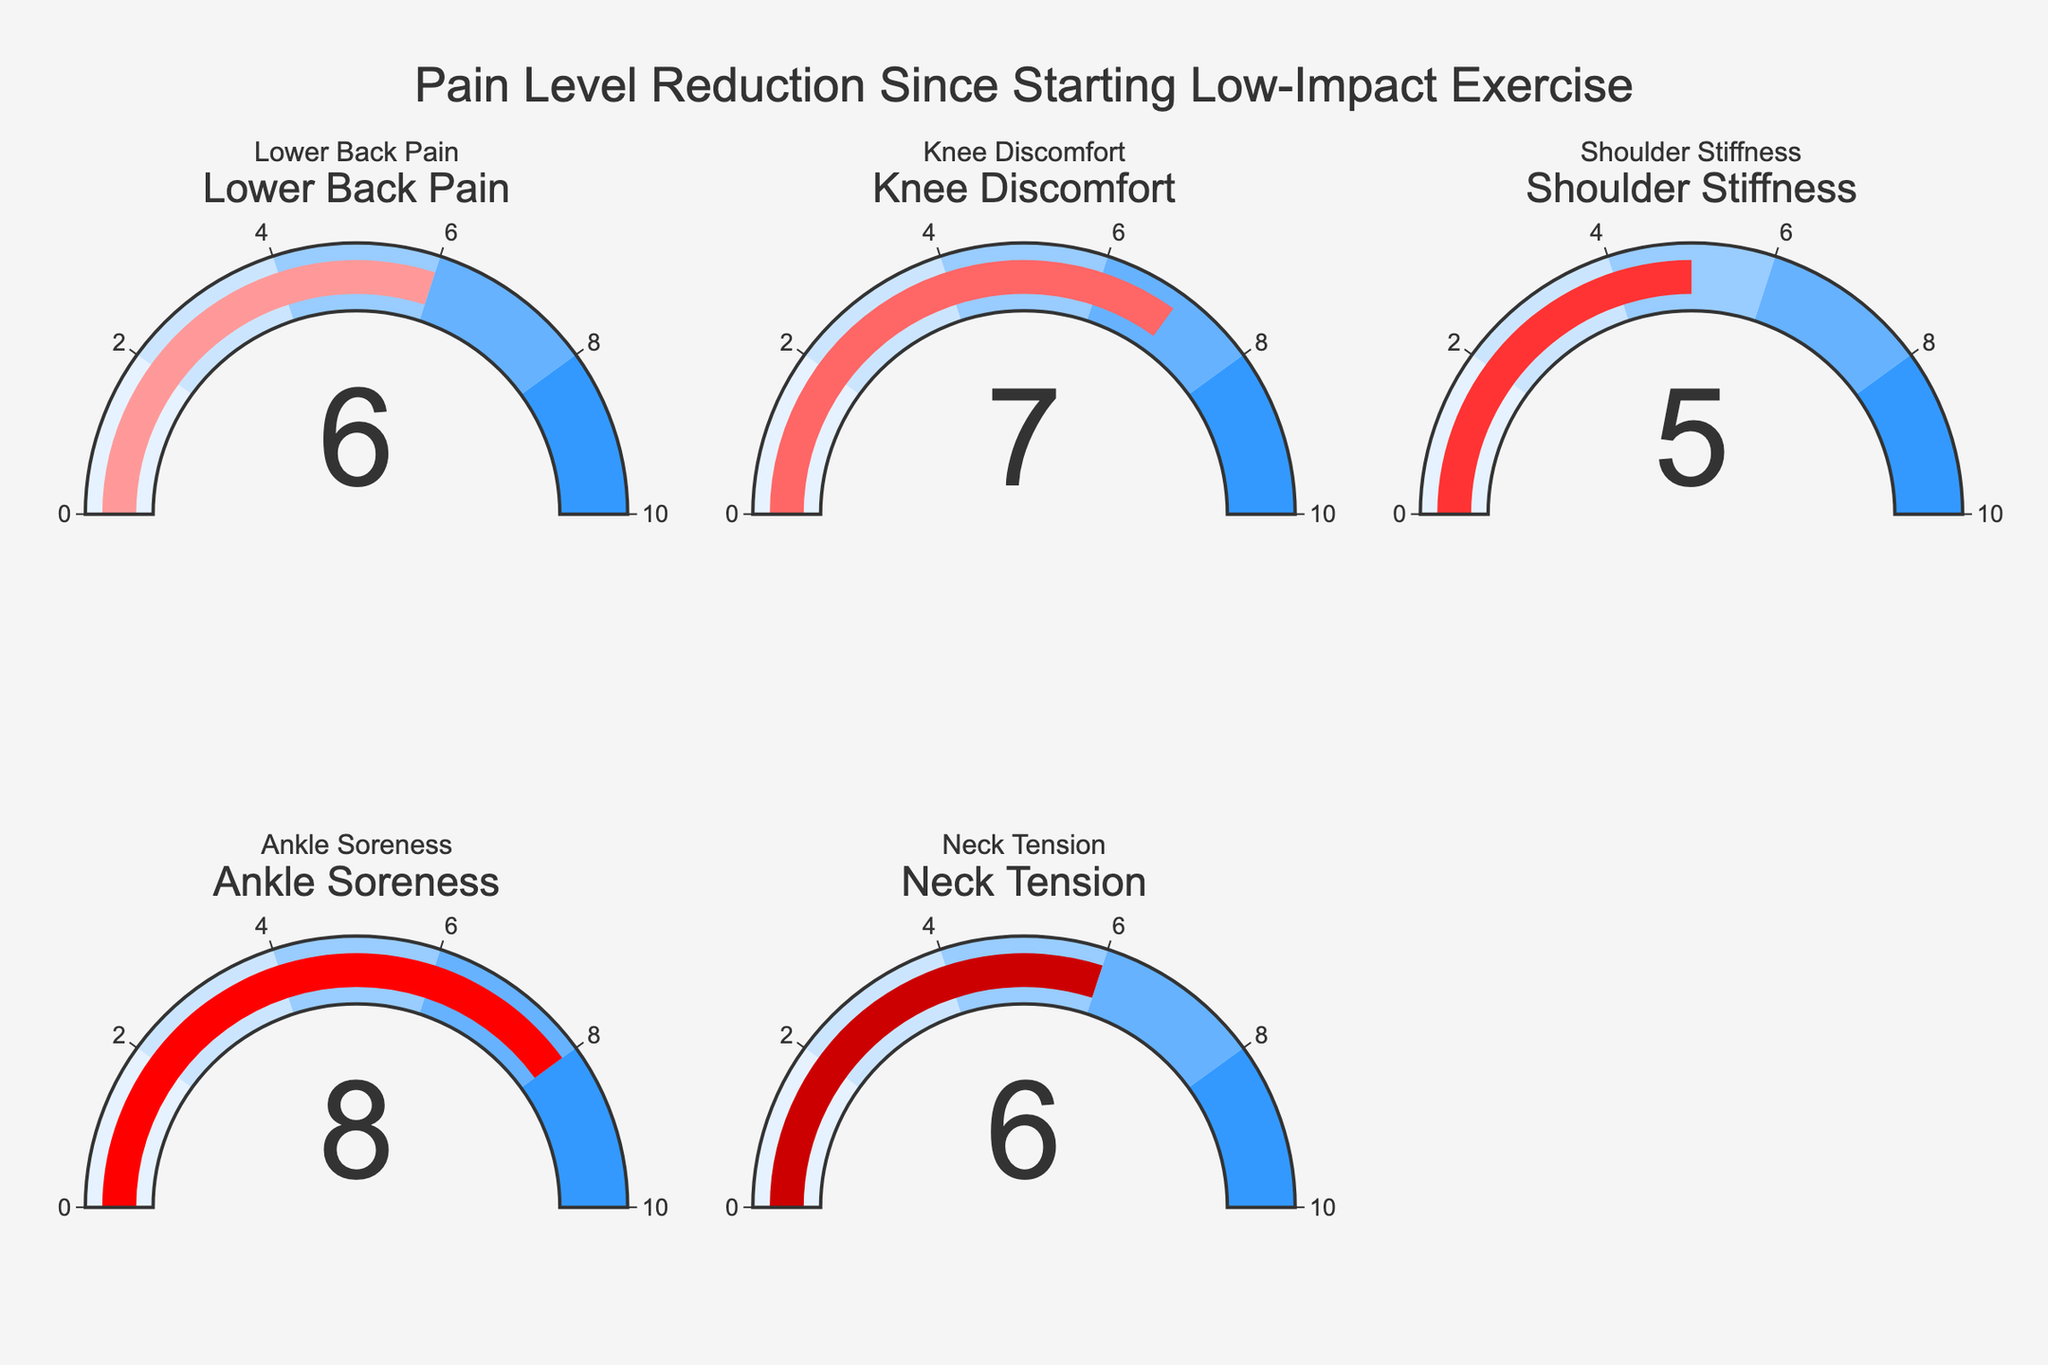How many pain types are displayed in the figure? Look at the number of gauges in the figure. There are a total of five gauges, each representing a different pain type.
Answer: Five Which pain type shows the highest reduction level? Identify the gauge with the highest value. The gauge for "Ankle Soreness" shows the highest reduction level at 8.
Answer: Ankle Soreness What is the average reduction level across all pain types? Add the reduction levels for all pain types: (6 + 7 + 5 + 8 + 6) = 32. Then divide by the number of pain types: 32 / 5 = 6.4.
Answer: 6.4 Which pain types have equal reduction levels? Compare the values on each gauge. Both "Lower Back Pain" and "Neck Tension" have a reduction level of 6.
Answer: Lower Back Pain and Neck Tension By how much is the reduction level of "Knee Discomfort" greater than that of "Shoulder Stiffness"? Subtract the reduction level of "Shoulder Stiffness" (5) from that of "Knee Discomfort" (7): 7 - 5 = 2.
Answer: 2 What is the combined reduction level for "Lower Back Pain" and "Shoulder Stiffness"? Add the reduction levels for "Lower Back Pain" (6) and "Shoulder Stiffness" (5): 6 + 5 = 11.
Answer: 11 How many pain types have a reduction level of 6? Count the gauges with a reduction level of 6. Both "Lower Back Pain" and "Neck Tension" have a reduction level of 6.
Answer: Two Which pain type has a lower reduction level: "Lower Back Pain" or "Neck Tension"? Compare the reduction levels of the two gauges. Both "Lower Back Pain" and "Neck Tension" show a reduction level of 6.
Answer: They are equal What is the range of the reduction levels displayed in the figure? The range is calculated by subtracting the smallest value from the largest value. The highest reduction level is 8 ("Ankle Soreness") and the lowest is 5 ("Shoulder Stiffness"), so the range is 8 - 5 = 3.
Answer: 3 What is the median reduction level of the pain types? List the reduction levels in ascending order: 5, 6, 6, 7, 8. The median value is the middle one in this sorted list, which is 6.
Answer: 6 